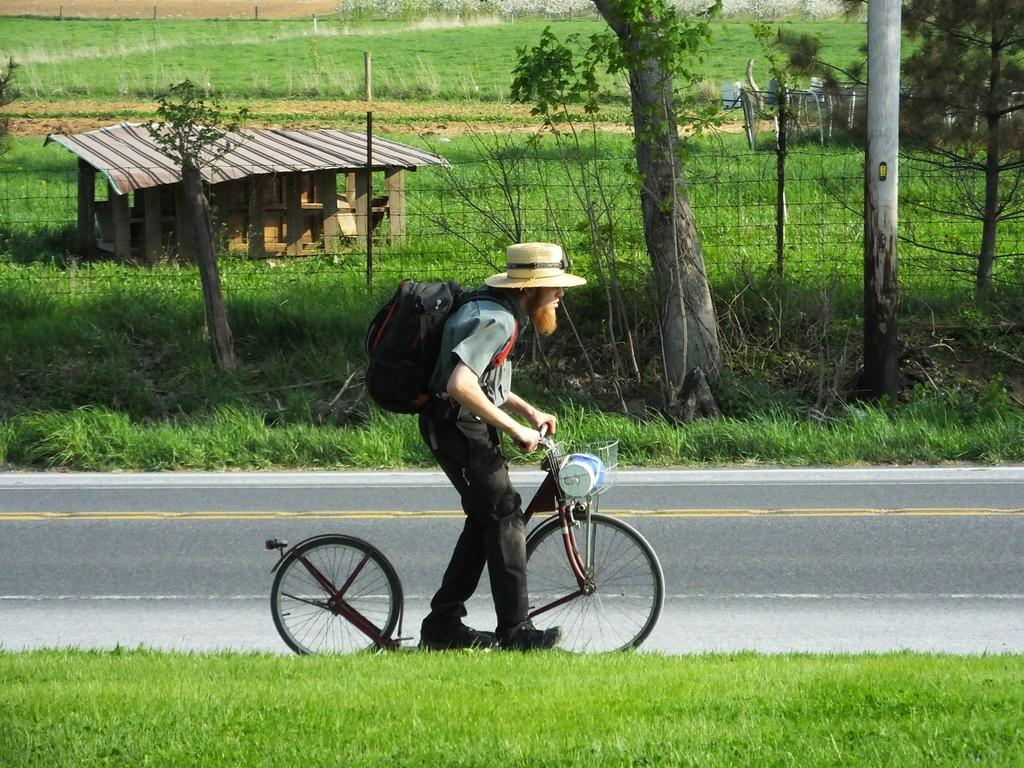What is the main subject of the image? The main subject of the image is a man. What is the man wearing in the image? The man is wearing a bag and a hat in the image. What is the man holding in the image? The man is holding a cycle in the image. What is the man doing in the image? The man is walking through a grass lawn in the image. What is visible beside the man in the image? There is a road beside the man in the image. What can be seen in the background of the image? In the background of the image, there is a tree, a house, and grass. How much wealth does the man have, as indicated by the coal in the image? There is no coal present in the image, so it is not possible to determine the man's wealth based on coal. 